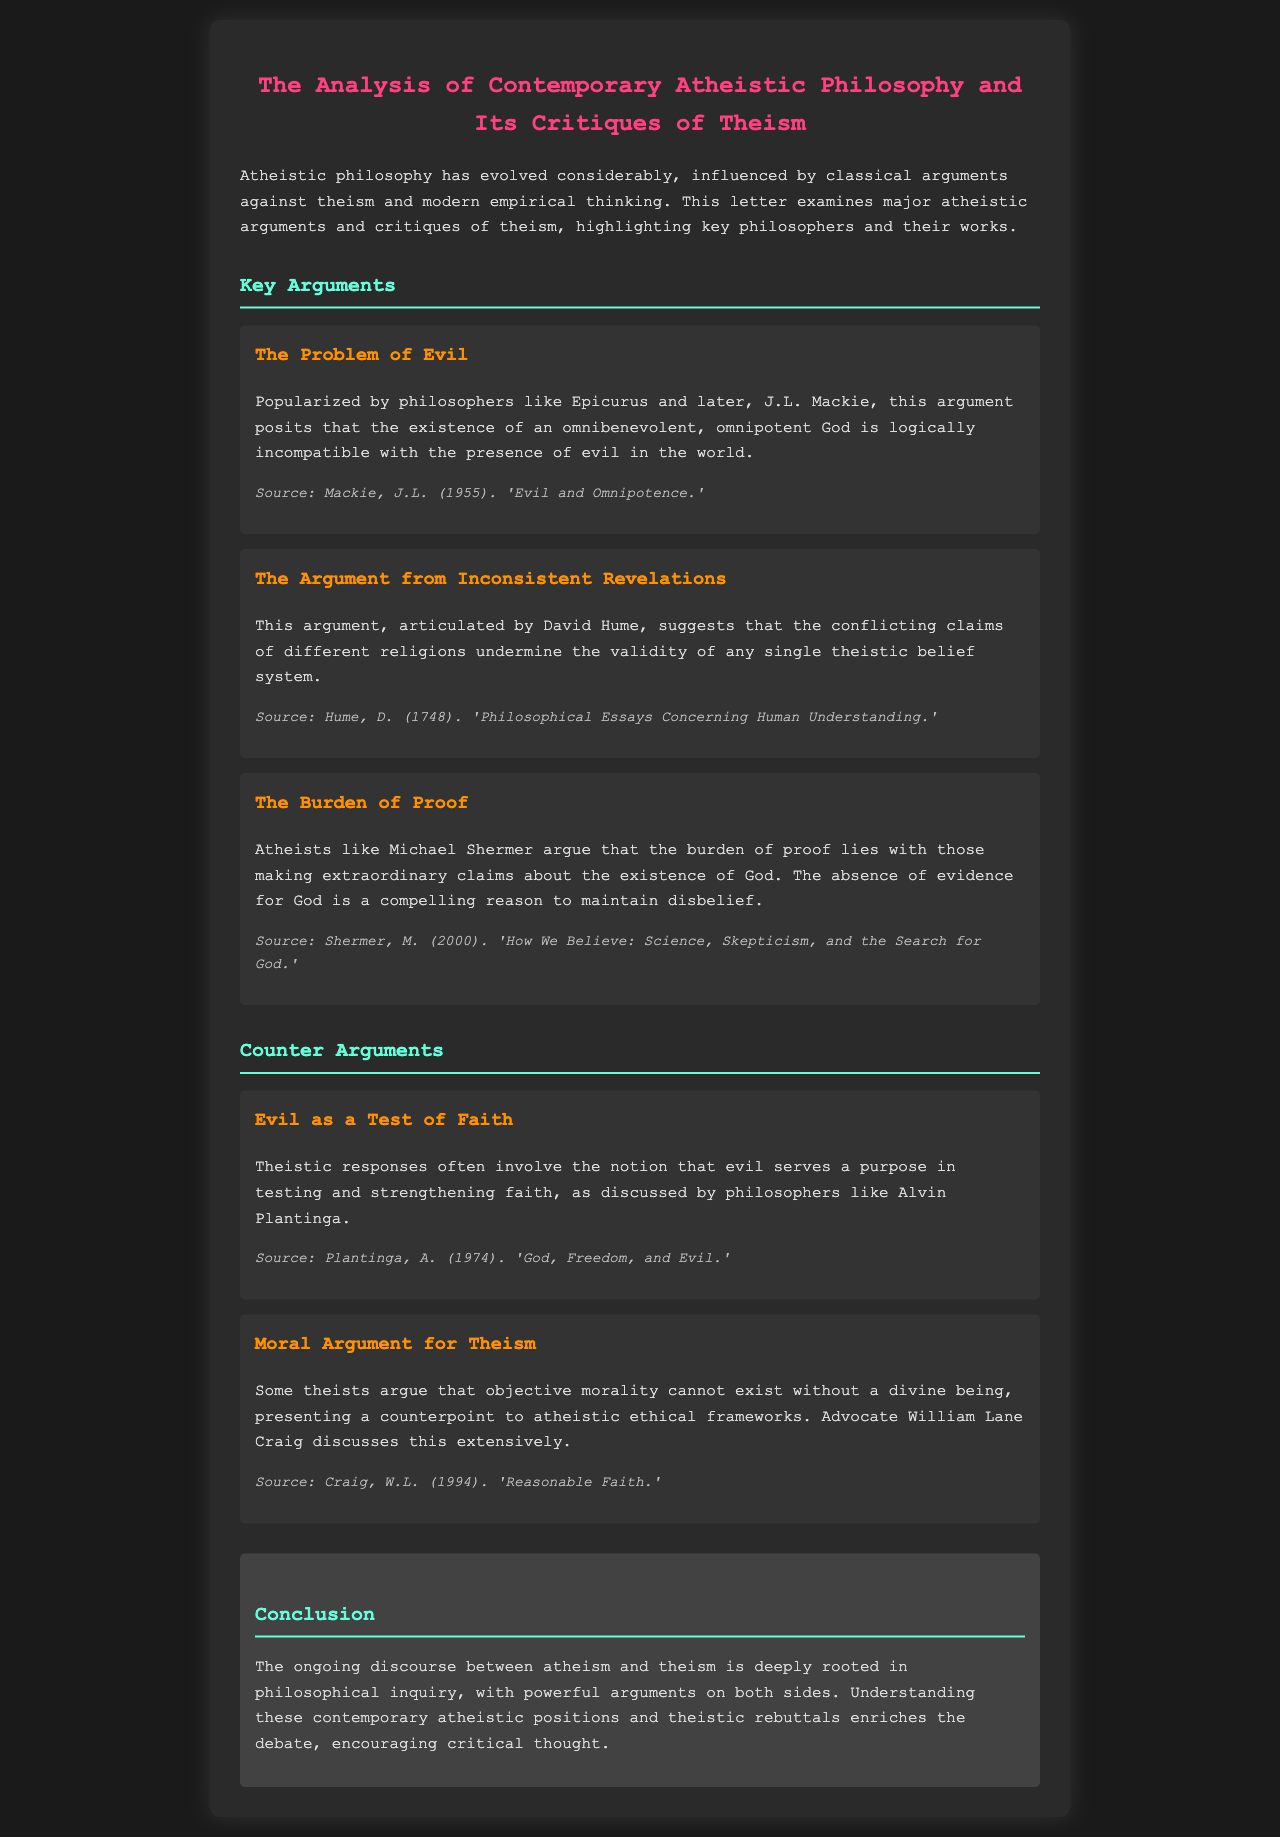What argument is popularized by Epicurus? Epicurus is associated with the Problem of Evil, which argues that the existence of an omnibenevolent, omnipotent God is logically incompatible with the presence of evil in the world.
Answer: Problem of Evil Who articulated the Argument from Inconsistent Revelations? This argument is articulated by David Hume, suggesting that the conflicting claims of different religions undermine any single theistic belief system.
Answer: David Hume What does Michael Shermer argue about the burden of proof? Michael Shermer argues that the burden of proof lies with those making extraordinary claims about the existence of God.
Answer: Extraordinary claims Which philosopher discusses evil serving a purpose in faith? Alvin Plantinga discusses the notion that evil serves a purpose in testing and strengthening faith.
Answer: Alvin Plantinga What is a counterpoint to atheistic ethical frameworks? The moral argument for theism presents a counterpoint, claiming that objective morality cannot exist without a divine being.
Answer: Objective morality What philosophical inquiry enriches the discourse between atheism and theism? The ongoing philosophical inquiry into atheism and theism, with powerful arguments on both sides, enriches the discourse.
Answer: Philosophical inquiry What is the primary theme of the letter? The primary theme is the analysis of contemporary atheistic philosophy and its critiques of theism.
Answer: Analysis of contemporary atheistic philosophy What is a source cited for the Problem of Evil? The source cited for the Problem of Evil is J.L. Mackie's 'Evil and Omnipotence.'
Answer: J.L. Mackie When was Hume's 'Philosophical Essays Concerning Human Understanding' published? Hume's work was published in 1748.
Answer: 1748 